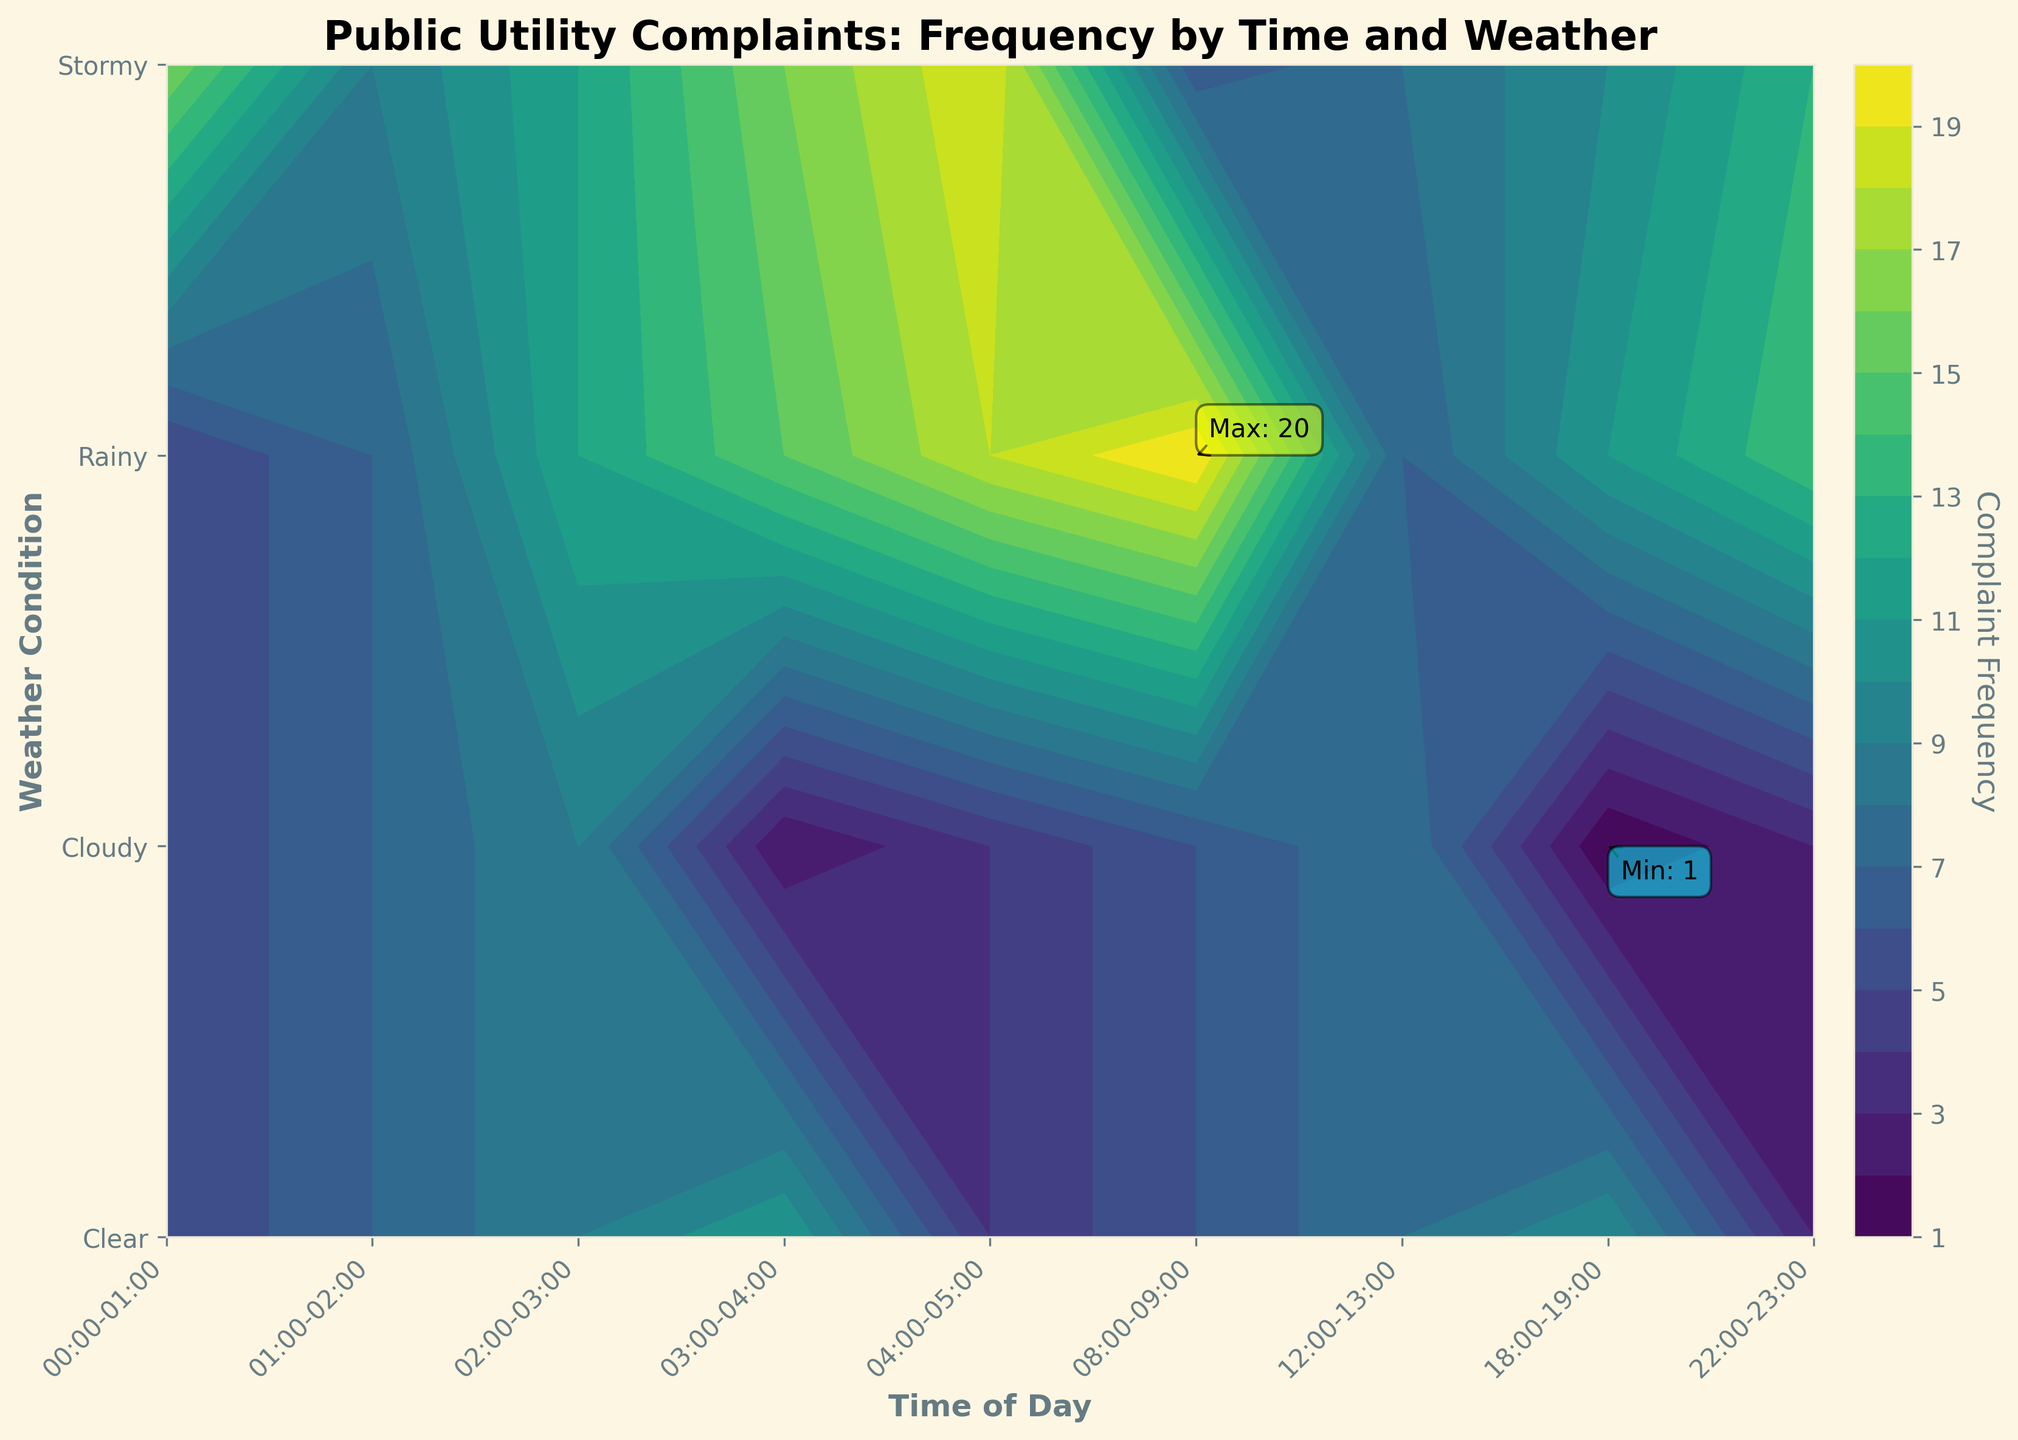When is the highest frequency of complaints during the day? The highest complaint frequency is indicated with an annotation on the plot pointing to the cell with the highest contour level. By looking at this annotation, the highest frequency of complaints occurs between 08:00-09:00, and the weather condition during this period is Stormy.
Answer: 08:00-09:00 What time of the day has the lowest frequency of complaints? The lowest complaint frequency is indicated by the annotation on the plot pointing to the cell with the lowest contour level. By looking at this annotation, the lowest frequency of complaints occurs between 04:00-05:00, and the weather condition is Clear.
Answer: 04:00-05:00 Compare the frequency of complaints in Rainy weather at 08:00-09:00 and 12:00-13:00. Which is higher? Referring to the contour plot's complaint frequencies at the specified times for Rainy weather, the frequency at 08:00-09:00 is 18, while at 12:00-13:00, it is 14. 18 is higher than 14.
Answer: 08:00-09:00 How does the complaint frequency typically trend from 00:00-01:00 to 04:00-05:00 in Stormy weather? To find the trend, observe the contour levels for the Stormy weather condition from 00:00-01:00 to 04:00-05:00. The frequencies start at 11, then follow through 10, 9, 8, and finally 7, showing a decreasing trend.
Answer: Decreasing What's the average complaint frequency for Clear weather? Sum the complaint frequencies for Clear weather across all times: 5 + 4 + 3 + 2 + 1 + 12 + 7 + 9 + 6 = 49. Then, divide by the number of time periods, which is 9: 49 / 9 = 5.44 (approx).
Answer: 5.44 Which weather condition sees the most variation in complaint frequency throughout the day? To determine the variation, observe the range of complaint frequencies for each weather condition. Stormy weather ranges from 7 (at 04:00-05:00) to 20 (at 08:00-09:00), showing a variation of 20 - 7 = 13. Compare with other conditions (Clear ranges 1 - 12 = 11, Cloudy 15 - 3 = 12, Rainy 18 - 5 = 13). Stormy and Rainy both have the highest range.
Answer: Stormy and Rainy What is the complaint frequency in Cloudy weather at 12:00-13:00? Referring to the contour levels for Cloudy weather at 12:00-13:00, the frequency is shown as 11.
Answer: 11 